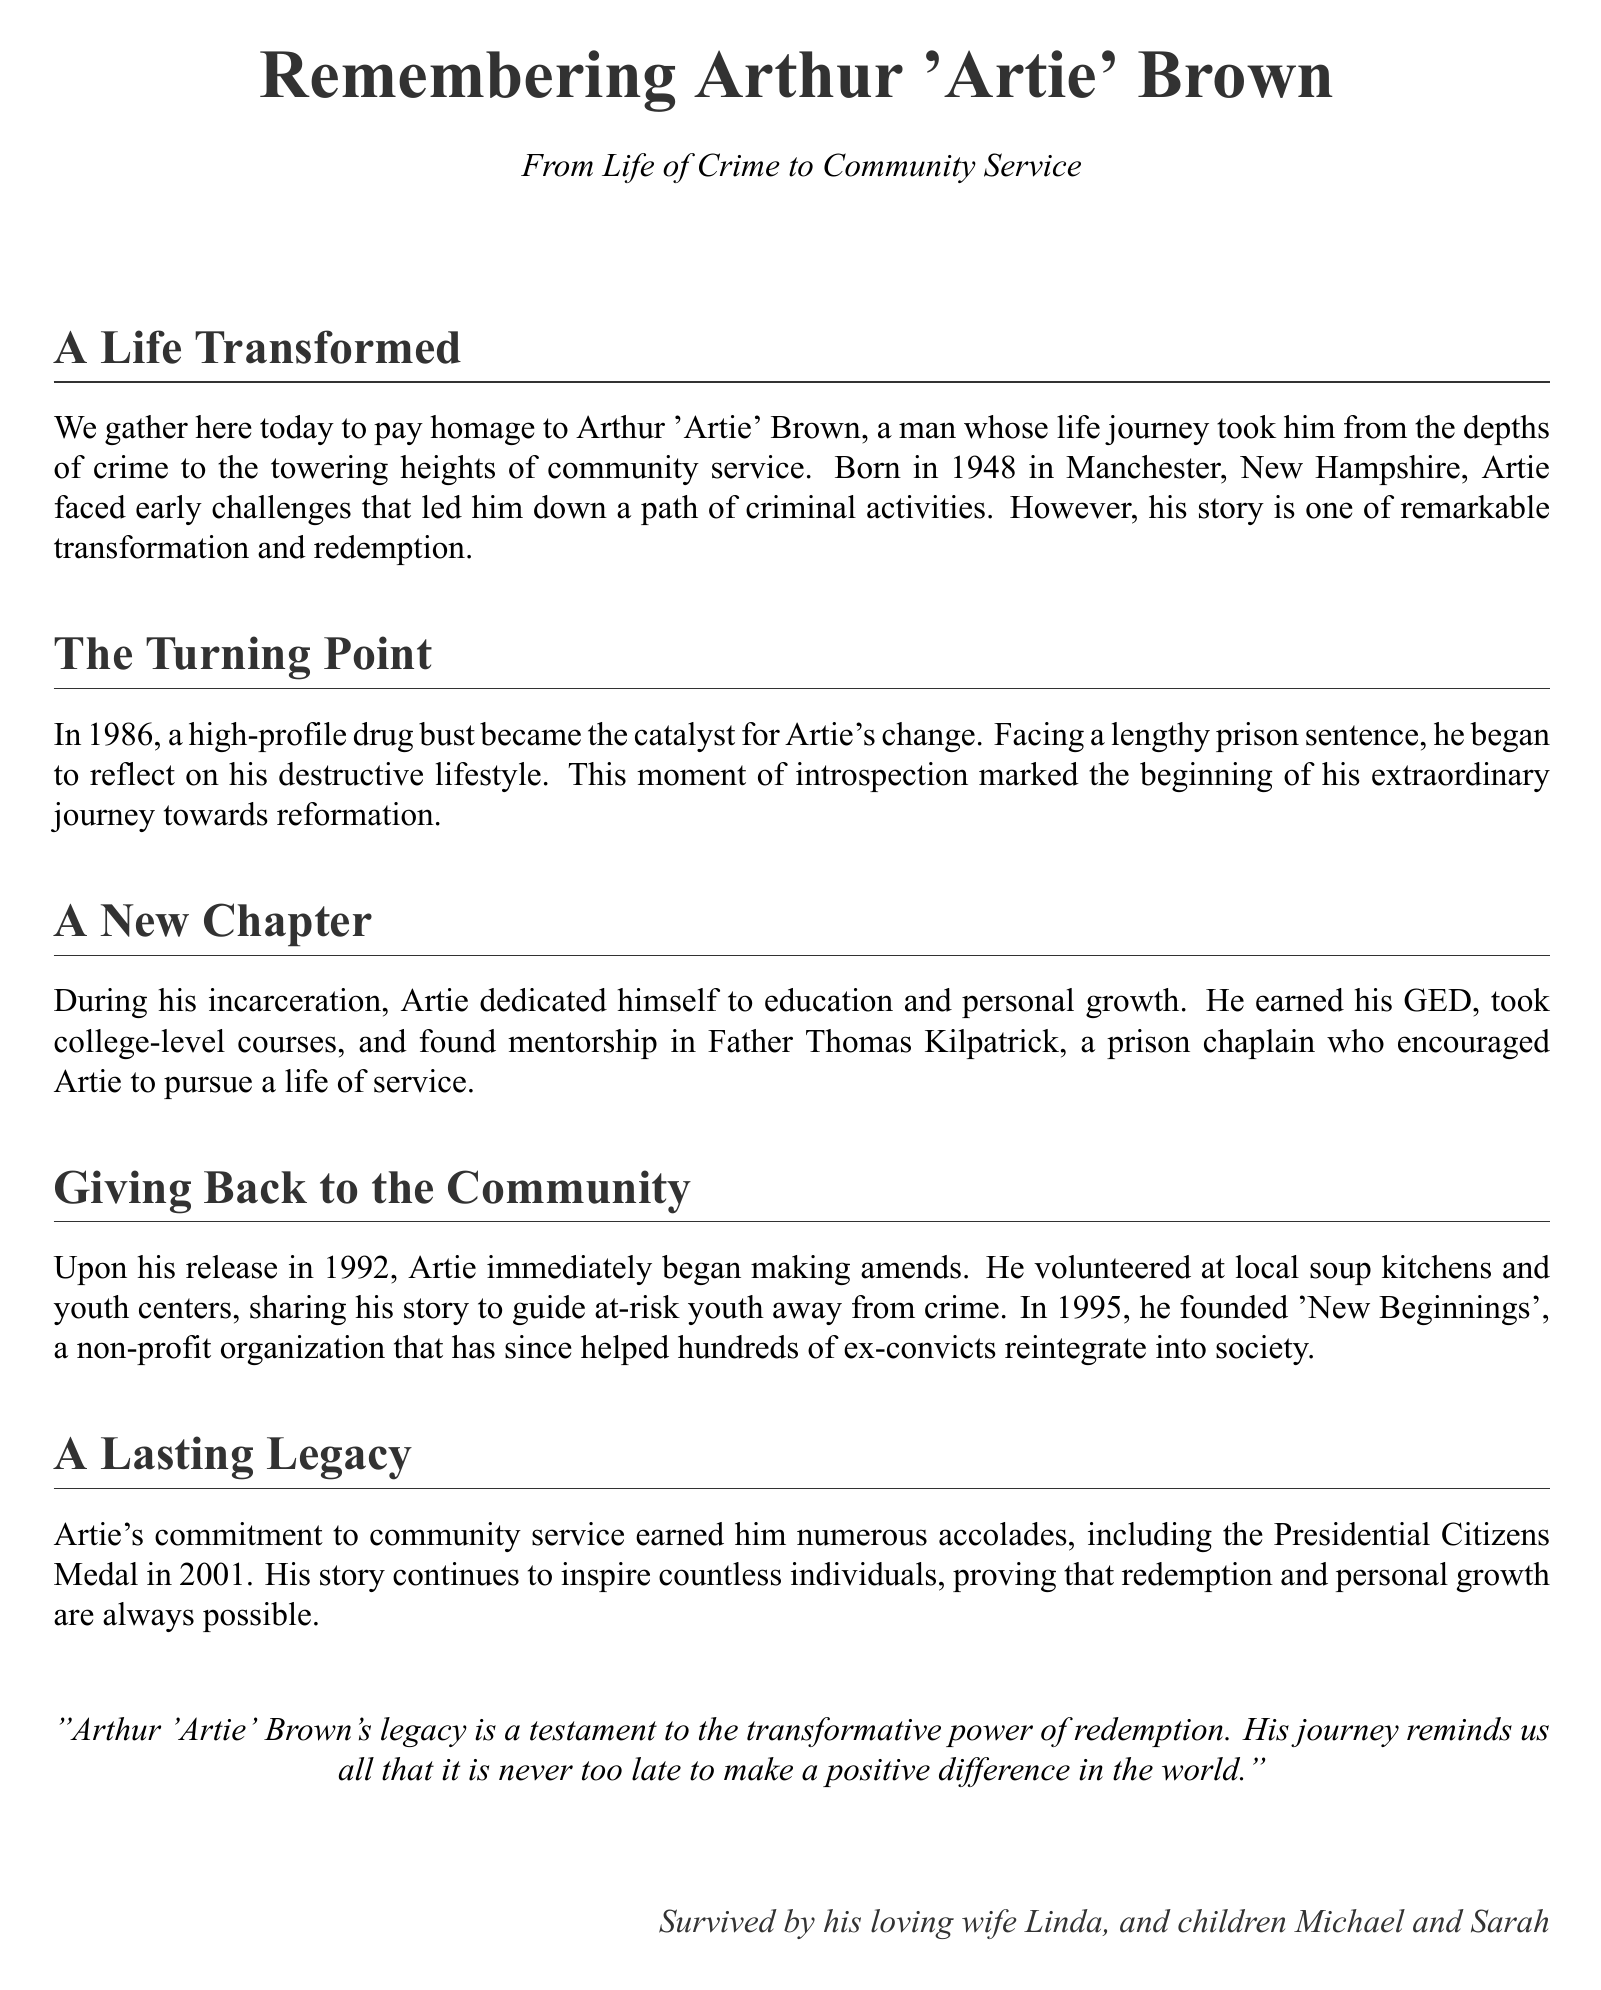What year was Arthur 'Artie' Brown born? The document states that Arthur 'Artie' Brown was born in 1948.
Answer: 1948 What was the turning point in Artie's life? The document mentions that a high-profile drug bust in 1986 became the catalyst for Artie's change.
Answer: High-profile drug bust What organization did Artie found in 1995? According to the document, Artie founded 'New Beginnings' in 1995.
Answer: New Beginnings Who encouraged Artie during his incarceration? The document identifies Father Thomas Kilpatrick as the mentor who encouraged Artie.
Answer: Father Thomas Kilpatrick What award did Artie receive in 2001? The document states that Artie received the Presidential Citizens Medal in 2001.
Answer: Presidential Citizens Medal What was Artie's primary focus after his release? The document explains that Artie focused on making amends and volunteering in his community.
Answer: Making amends What does Artie's story exemplify? The text suggests that Artie's journey exemplifies the transformative power of redemption.
Answer: Transformative power of redemption How did Artie's past influence his community work? The document indicates that Artie shared his story to guide at-risk youth away from crime.
Answer: Guided at-risk youth How many children did Artie have? The document mentions that Artie is survived by his children Michael and Sarah, thus he had two children.
Answer: Two children 